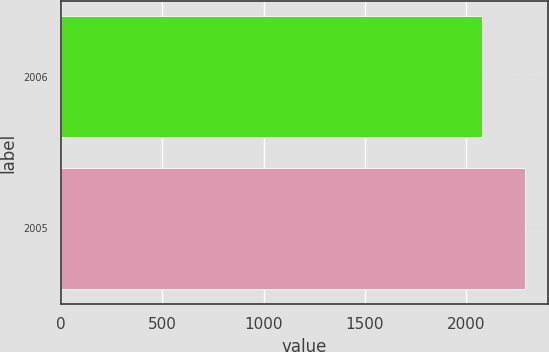Convert chart. <chart><loc_0><loc_0><loc_500><loc_500><bar_chart><fcel>2006<fcel>2005<nl><fcel>2079<fcel>2288.1<nl></chart> 